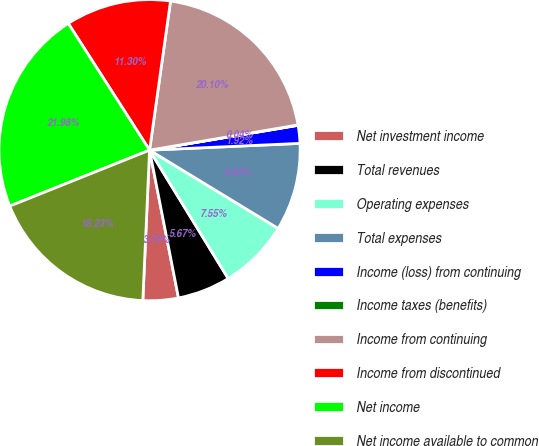Convert chart to OTSL. <chart><loc_0><loc_0><loc_500><loc_500><pie_chart><fcel>Net investment income<fcel>Total revenues<fcel>Operating expenses<fcel>Total expenses<fcel>Income (loss) from continuing<fcel>Income taxes (benefits)<fcel>Income from continuing<fcel>Income from discontinued<fcel>Net income<fcel>Net income available to common<nl><fcel>3.79%<fcel>5.67%<fcel>7.55%<fcel>9.42%<fcel>1.92%<fcel>0.04%<fcel>20.1%<fcel>11.3%<fcel>21.98%<fcel>18.23%<nl></chart> 